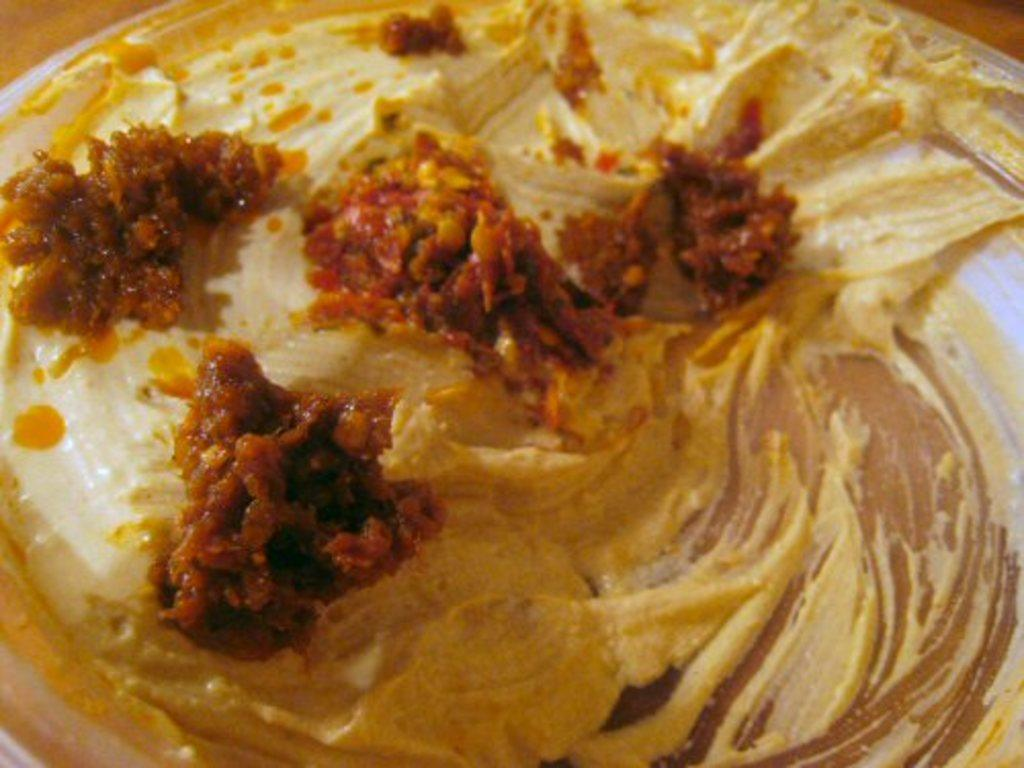What type of food item is in the bowl in the image? There is a bowl with a gravy food item in the image. What is the gravy food item placed on? The gravy food item is on a cream. Are there any platforms visible in the image? Yes, there are platforms at the top left and top right corners of the image. How many rabbits can be seen eating apples in the image? There are no rabbits or apples present in the image. Can you describe the cats in the image? There are no cats present in the image. 